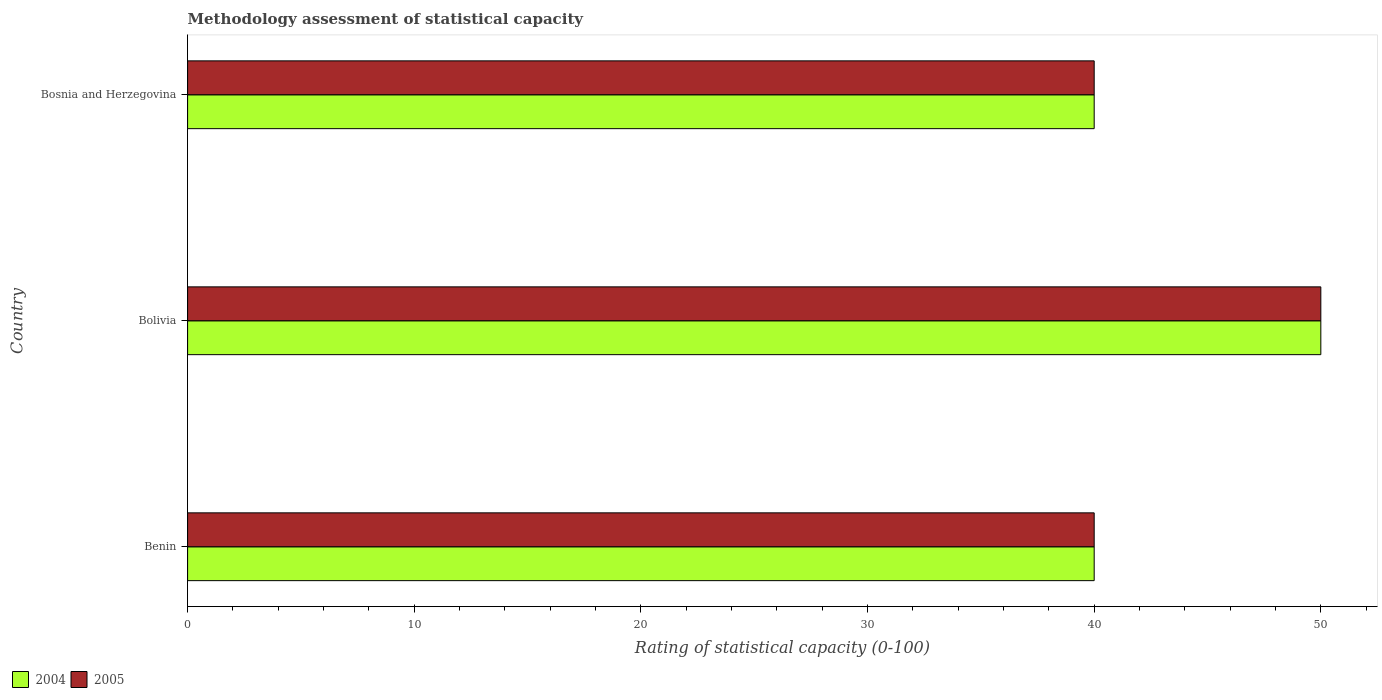How many different coloured bars are there?
Keep it short and to the point. 2. How many groups of bars are there?
Provide a succinct answer. 3. Are the number of bars per tick equal to the number of legend labels?
Provide a succinct answer. Yes. Are the number of bars on each tick of the Y-axis equal?
Ensure brevity in your answer.  Yes. What is the label of the 3rd group of bars from the top?
Offer a very short reply. Benin. What is the rating of statistical capacity in 2004 in Bolivia?
Keep it short and to the point. 50. In which country was the rating of statistical capacity in 2004 maximum?
Make the answer very short. Bolivia. In which country was the rating of statistical capacity in 2004 minimum?
Ensure brevity in your answer.  Benin. What is the total rating of statistical capacity in 2005 in the graph?
Give a very brief answer. 130. What is the difference between the rating of statistical capacity in 2004 in Benin and the rating of statistical capacity in 2005 in Bolivia?
Provide a succinct answer. -10. What is the average rating of statistical capacity in 2004 per country?
Keep it short and to the point. 43.33. In how many countries, is the rating of statistical capacity in 2005 greater than 40 ?
Offer a very short reply. 1. Is the rating of statistical capacity in 2004 in Benin less than that in Bolivia?
Your answer should be very brief. Yes. Is the difference between the rating of statistical capacity in 2005 in Benin and Bolivia greater than the difference between the rating of statistical capacity in 2004 in Benin and Bolivia?
Keep it short and to the point. No. What is the difference between the highest and the second highest rating of statistical capacity in 2004?
Offer a very short reply. 10. In how many countries, is the rating of statistical capacity in 2005 greater than the average rating of statistical capacity in 2005 taken over all countries?
Provide a succinct answer. 1. Is the sum of the rating of statistical capacity in 2004 in Benin and Bosnia and Herzegovina greater than the maximum rating of statistical capacity in 2005 across all countries?
Offer a very short reply. Yes. What does the 1st bar from the top in Bosnia and Herzegovina represents?
Your answer should be very brief. 2005. How many bars are there?
Keep it short and to the point. 6. Are all the bars in the graph horizontal?
Make the answer very short. Yes. How many countries are there in the graph?
Ensure brevity in your answer.  3. Are the values on the major ticks of X-axis written in scientific E-notation?
Give a very brief answer. No. Where does the legend appear in the graph?
Provide a succinct answer. Bottom left. How are the legend labels stacked?
Ensure brevity in your answer.  Horizontal. What is the title of the graph?
Your response must be concise. Methodology assessment of statistical capacity. Does "1979" appear as one of the legend labels in the graph?
Your answer should be very brief. No. What is the label or title of the X-axis?
Keep it short and to the point. Rating of statistical capacity (0-100). What is the Rating of statistical capacity (0-100) of 2004 in Benin?
Make the answer very short. 40. What is the Rating of statistical capacity (0-100) in 2005 in Benin?
Your answer should be compact. 40. What is the Rating of statistical capacity (0-100) of 2005 in Bolivia?
Your response must be concise. 50. What is the Rating of statistical capacity (0-100) in 2004 in Bosnia and Herzegovina?
Provide a short and direct response. 40. Across all countries, what is the maximum Rating of statistical capacity (0-100) in 2004?
Provide a succinct answer. 50. Across all countries, what is the maximum Rating of statistical capacity (0-100) in 2005?
Offer a terse response. 50. Across all countries, what is the minimum Rating of statistical capacity (0-100) of 2004?
Your answer should be very brief. 40. What is the total Rating of statistical capacity (0-100) of 2004 in the graph?
Your answer should be very brief. 130. What is the total Rating of statistical capacity (0-100) in 2005 in the graph?
Keep it short and to the point. 130. What is the difference between the Rating of statistical capacity (0-100) of 2004 in Benin and that in Bolivia?
Your answer should be compact. -10. What is the difference between the Rating of statistical capacity (0-100) of 2005 in Benin and that in Bolivia?
Your response must be concise. -10. What is the difference between the Rating of statistical capacity (0-100) in 2004 in Benin and that in Bosnia and Herzegovina?
Offer a very short reply. 0. What is the difference between the Rating of statistical capacity (0-100) of 2005 in Benin and that in Bosnia and Herzegovina?
Provide a short and direct response. 0. What is the difference between the Rating of statistical capacity (0-100) in 2004 in Bolivia and that in Bosnia and Herzegovina?
Ensure brevity in your answer.  10. What is the difference between the Rating of statistical capacity (0-100) in 2005 in Bolivia and that in Bosnia and Herzegovina?
Your response must be concise. 10. What is the difference between the Rating of statistical capacity (0-100) in 2004 in Bolivia and the Rating of statistical capacity (0-100) in 2005 in Bosnia and Herzegovina?
Your answer should be very brief. 10. What is the average Rating of statistical capacity (0-100) in 2004 per country?
Ensure brevity in your answer.  43.33. What is the average Rating of statistical capacity (0-100) of 2005 per country?
Ensure brevity in your answer.  43.33. What is the difference between the Rating of statistical capacity (0-100) in 2004 and Rating of statistical capacity (0-100) in 2005 in Benin?
Your response must be concise. 0. What is the difference between the Rating of statistical capacity (0-100) of 2004 and Rating of statistical capacity (0-100) of 2005 in Bolivia?
Make the answer very short. 0. What is the difference between the Rating of statistical capacity (0-100) in 2004 and Rating of statistical capacity (0-100) in 2005 in Bosnia and Herzegovina?
Keep it short and to the point. 0. What is the ratio of the Rating of statistical capacity (0-100) of 2005 in Benin to that in Bolivia?
Your answer should be very brief. 0.8. What is the ratio of the Rating of statistical capacity (0-100) of 2004 in Benin to that in Bosnia and Herzegovina?
Offer a terse response. 1. What is the difference between the highest and the second highest Rating of statistical capacity (0-100) of 2005?
Offer a very short reply. 10. What is the difference between the highest and the lowest Rating of statistical capacity (0-100) of 2004?
Your answer should be very brief. 10. What is the difference between the highest and the lowest Rating of statistical capacity (0-100) in 2005?
Provide a succinct answer. 10. 